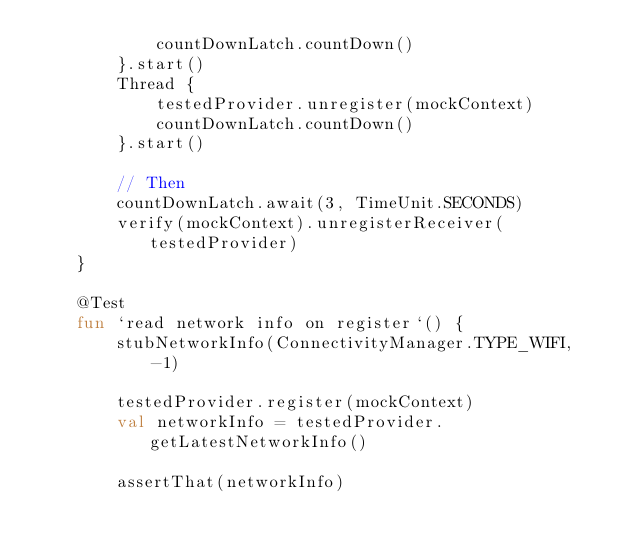<code> <loc_0><loc_0><loc_500><loc_500><_Kotlin_>            countDownLatch.countDown()
        }.start()
        Thread {
            testedProvider.unregister(mockContext)
            countDownLatch.countDown()
        }.start()

        // Then
        countDownLatch.await(3, TimeUnit.SECONDS)
        verify(mockContext).unregisterReceiver(testedProvider)
    }

    @Test
    fun `read network info on register`() {
        stubNetworkInfo(ConnectivityManager.TYPE_WIFI, -1)

        testedProvider.register(mockContext)
        val networkInfo = testedProvider.getLatestNetworkInfo()

        assertThat(networkInfo)</code> 